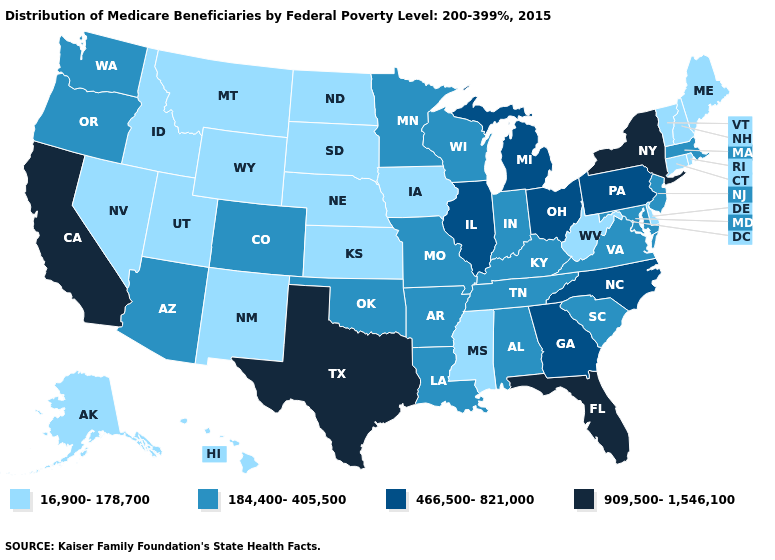Which states have the highest value in the USA?
Write a very short answer. California, Florida, New York, Texas. Which states have the highest value in the USA?
Give a very brief answer. California, Florida, New York, Texas. Does New Jersey have the same value as Virginia?
Keep it brief. Yes. What is the value of Utah?
Give a very brief answer. 16,900-178,700. Among the states that border Rhode Island , which have the highest value?
Give a very brief answer. Massachusetts. What is the value of New Mexico?
Keep it brief. 16,900-178,700. Among the states that border Indiana , which have the lowest value?
Short answer required. Kentucky. What is the value of Texas?
Concise answer only. 909,500-1,546,100. Name the states that have a value in the range 184,400-405,500?
Keep it brief. Alabama, Arizona, Arkansas, Colorado, Indiana, Kentucky, Louisiana, Maryland, Massachusetts, Minnesota, Missouri, New Jersey, Oklahoma, Oregon, South Carolina, Tennessee, Virginia, Washington, Wisconsin. Among the states that border Massachusetts , which have the lowest value?
Short answer required. Connecticut, New Hampshire, Rhode Island, Vermont. Among the states that border Montana , which have the lowest value?
Write a very short answer. Idaho, North Dakota, South Dakota, Wyoming. Does the first symbol in the legend represent the smallest category?
Quick response, please. Yes. Among the states that border Kentucky , does Indiana have the highest value?
Keep it brief. No. What is the value of Virginia?
Answer briefly. 184,400-405,500. What is the highest value in states that border Montana?
Write a very short answer. 16,900-178,700. 